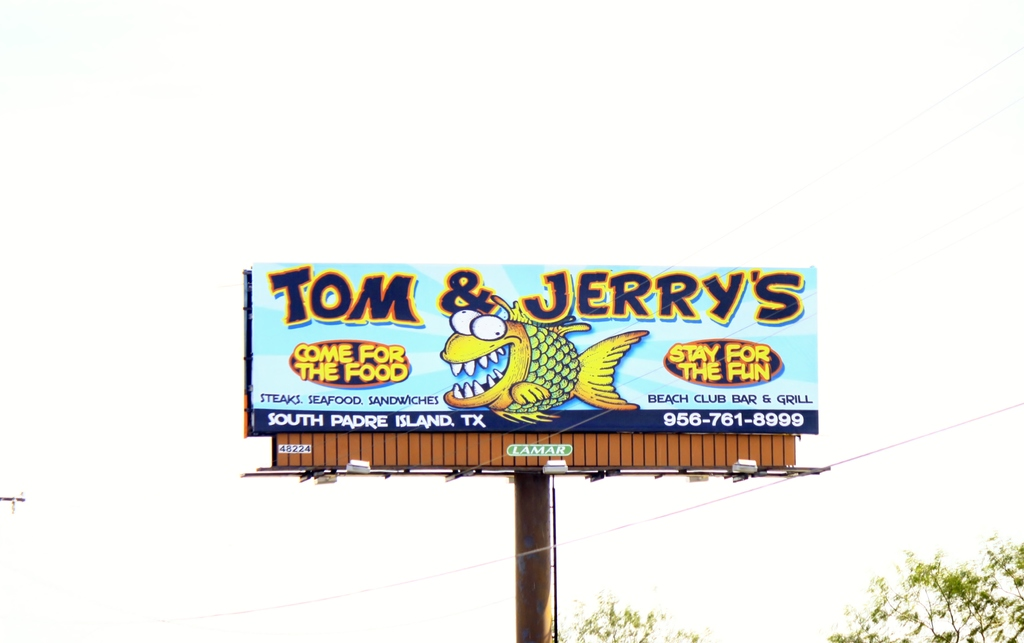What do you think is going on in this snapshot? The image shows a vividly colored billboard advertising 'Tom & Jerry's Beach Club Bar & Grill' in South Padre Island, Texas. The billboard features a lively cartoon alligator, probably the mascot, which aligns with the playful tone of the slogan 'Come for the food, stay for the fun'. It promotes a variety of offerings including steaks, seafood, and sandwiches, which suggests a versatile menu aimed at a wide audience. The cheerful and inviting presentation hints at a family-friendly atmosphere within a beach setting, making it an appealing destination for both locals and tourists. The clear display of the phone number '956-761-8999' provides a direct way for potential visitors to make inquiries or reservations. 